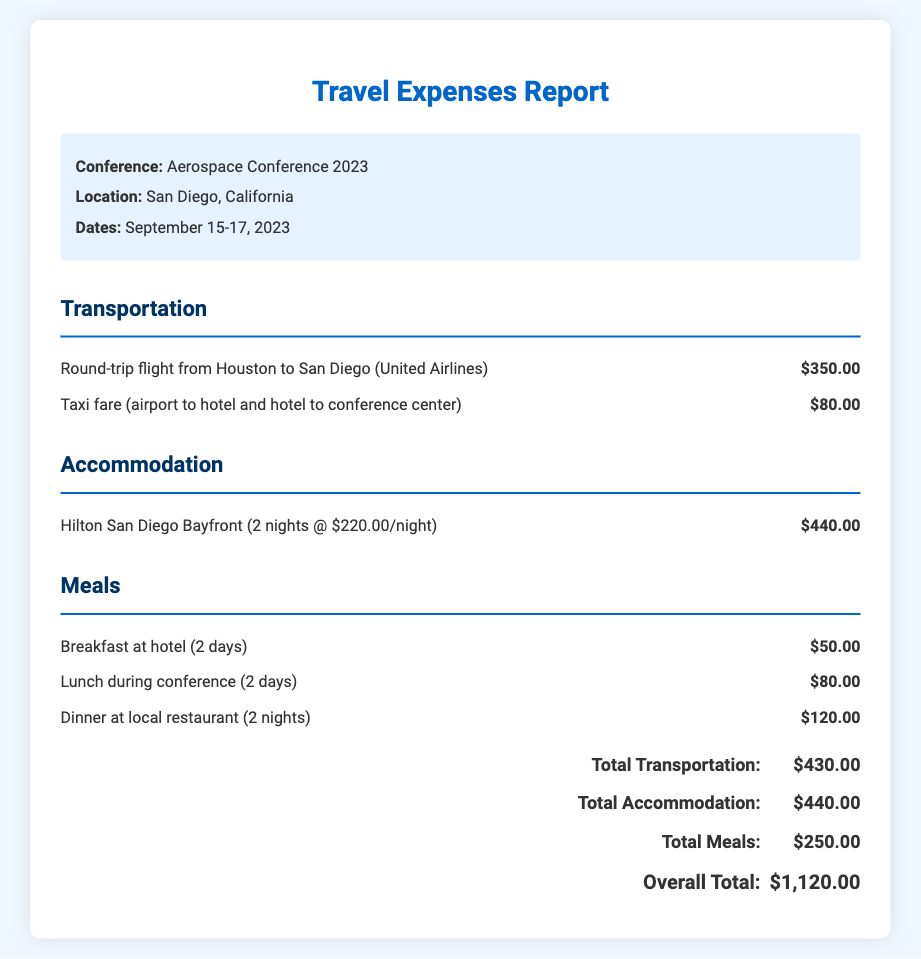What is the total cost of the round-trip flight? The cost of the round-trip flight from Houston to San Diego is listed in the transportation section, which is $350.00.
Answer: $350.00 How many nights was the accommodation booked for? The accommodation section states that the stay at Hilton San Diego Bayfront was for 2 nights.
Answer: 2 nights What is the total amount spent on meals? The meal costs are summed up in the document, totaling $250.00.
Answer: $250.00 What hotel was used for accommodation? The document specifies that Hilton San Diego Bayfront was the hotel used for accommodation.
Answer: Hilton San Diego Bayfront How much was spent on taxi fare? The taxi fare is listed under transportation, with the cost being $80.00.
Answer: $80.00 What was the overall total cost for the trip? The overall total is calculated by summing all expenses, which amounts to $1,120.00.
Answer: $1,120.00 What are the dates of the conference? The document mentions that the conference dates are September 15-17, 2023.
Answer: September 15-17, 2023 How much was spent per night for the hotel stay? The accommodation section indicates that the hotel rate was $220.00 per night.
Answer: $220.00 How many days of breakfast were charged? The document states that breakfast at the hotel was charged for 2 days.
Answer: 2 days 